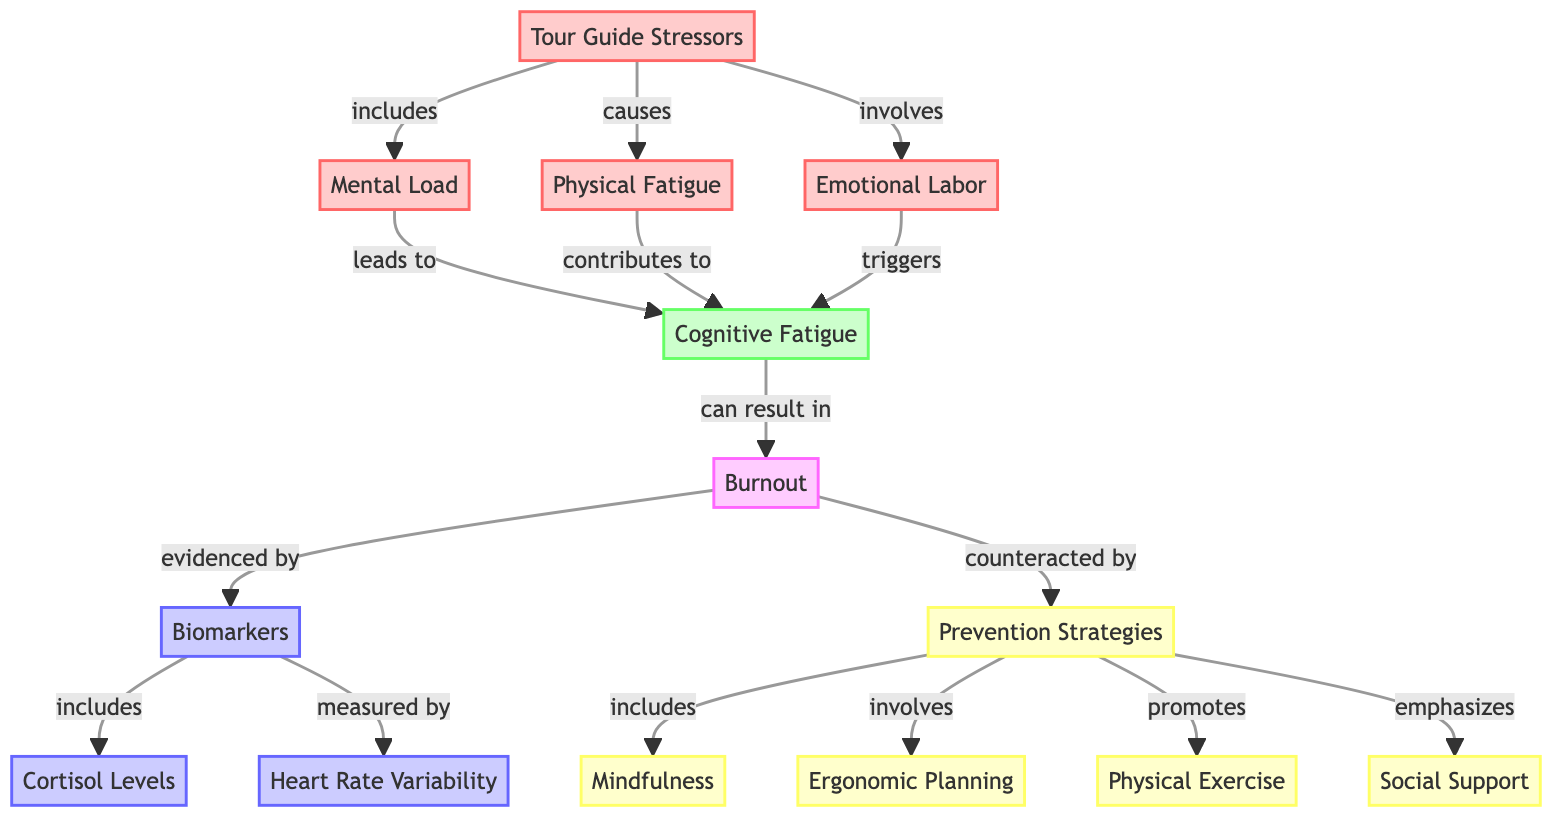What are the primary tour guide stressors? The diagram indicates that the primary tour guide stressors include Mental Load, Physical Fatigue, and Emotional Labor. These three elements branch directly from the Tour Guide Stressors node, showing a clear relationship.
Answer: Mental Load, Physical Fatigue, Emotional Labor How does Mental Load affect Cognitive Fatigue? The diagram shows a direct arrow from Mental Load to Cognitive Fatigue, indicating that Mental Load leads to Cognitive Fatigue as a result of increased mental demands on the tour guides.
Answer: Leads to What are the biomarkers related to Burnout? The diagram identifies two biomarkers related to Burnout: Cortisol Levels and Heart Rate Variability, which are listed under the Biomarkers node that links from the Burnout node.
Answer: Cortisol Levels, Heart Rate Variability What contributes to Cognitive Fatigue? The diagram specifies that both Physical Fatigue and Emotional Labor contribute to Cognitive Fatigue, highlighting that both stressors are factors in its development.
Answer: Physical Fatigue, Emotional Labor What strategies can counteract Burnout? According to the diagram, the strategies that can counteract Burnout include Mindfulness, Ergonomic Planning, Physical Exercise, and Social Support, which are listed under the Prevention Strategies node that connects to the Burnout node.
Answer: Mindfulness, Ergonomic Planning, Physical Exercise, Social Support What is the relationship between Burnout and Biomarkers? The diagram illustrates that Burnout is evidenced by Biomarkers, meaning that Burnout can be confirmed or supported through the presence of these biomarkers, providing a link between them.
Answer: Evidenced by Which prevention strategy promotes Physical Exercise? The diagram indicates that the Prevention Strategies node includes Physical Exercise, and it is specifically noted as one of the aspects that the Prevention Strategies promotes.
Answer: Promotes How many nodes are there related to prevention strategies? By analyzing the Prevention Strategies node in the diagram, we see that there are four distinct strategies listed, thus quantifying the nodes connected to this category.
Answer: Four What triggers Cognitive Fatigue? According to the diagram, Emotional Labor triggers Cognitive Fatigue, showing a direct link that highlights the impact of emotional work on cognitive performance in tour guides.
Answer: Triggers 